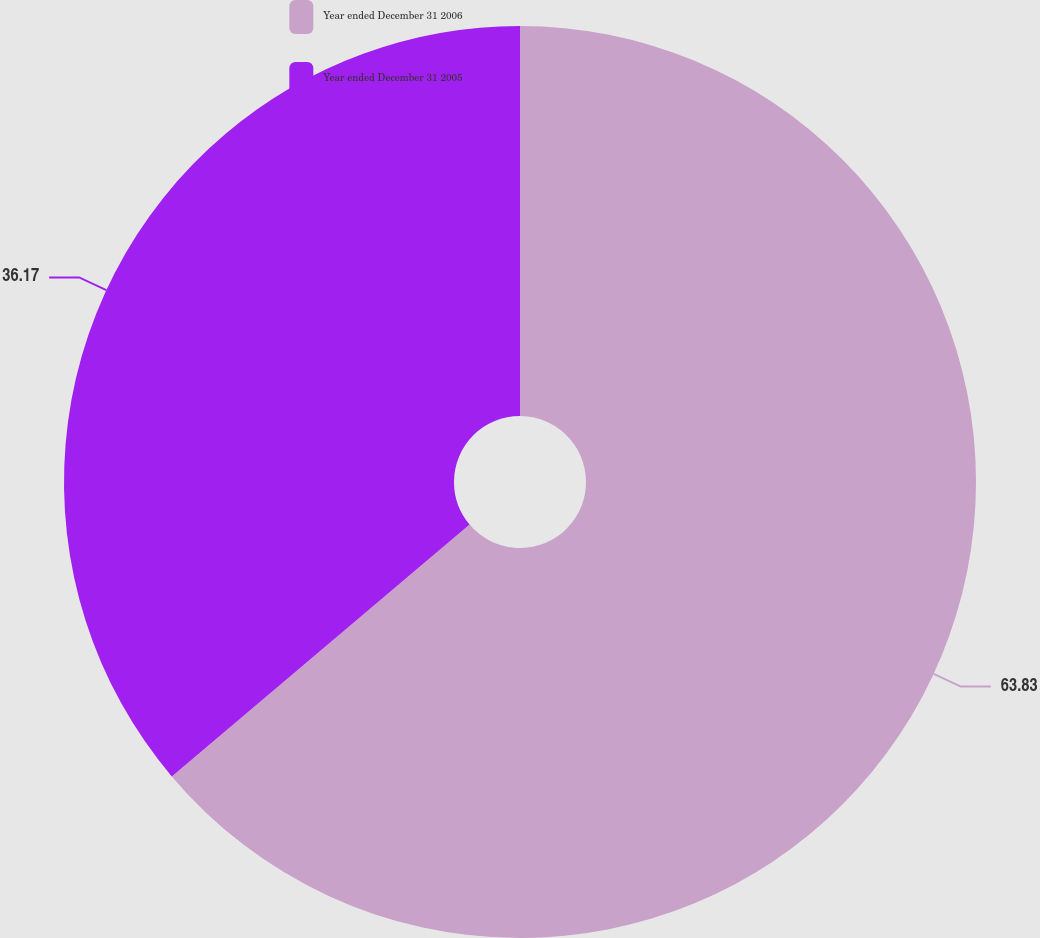<chart> <loc_0><loc_0><loc_500><loc_500><pie_chart><fcel>Year ended December 31 2006<fcel>Year ended December 31 2005<nl><fcel>63.83%<fcel>36.17%<nl></chart> 